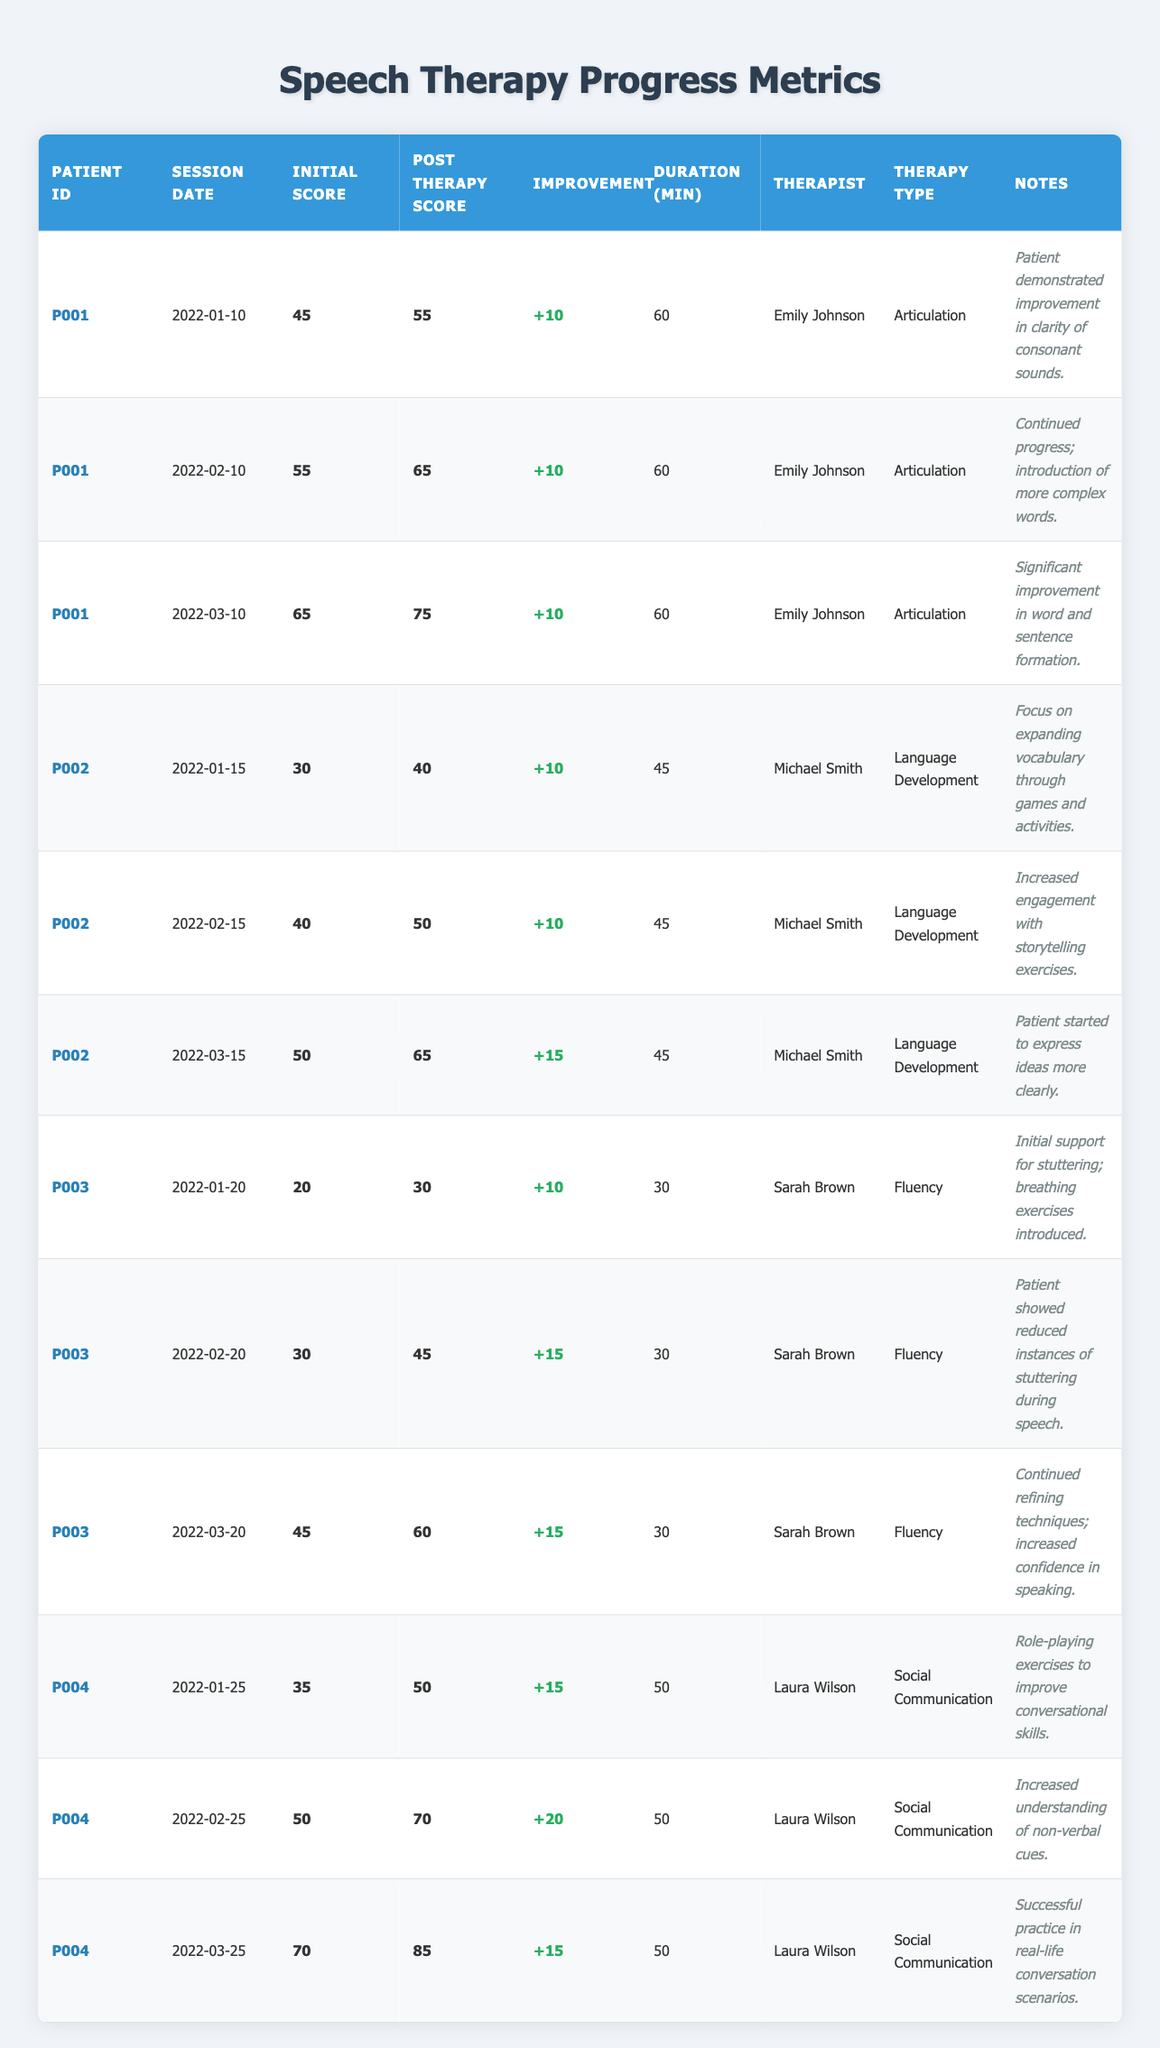What is the improvement score for patient P001 on the last session? In the last session for patient P001 on 2022-03-10, the post therapy score was 75 and the initial score was 65. Improvement is calculated as 75 - 65 = 10.
Answer: 10 Which therapist worked with patient P002 during the second session? During the second session on 2022-02-15, the therapist for patient P002 was Michael Smith, as noted in the table.
Answer: Michael Smith How much total improvement did patient P004 achieve from their first session to their last session? For patient P004, the initial score in the first session (2022-01-25) was 35 and the post therapy score in the last session (2022-03-25) was 85. Total improvement is calculated as 85 - 35 = 50.
Answer: 50 Did patient P003 show improvement in all their therapy sessions? In reviewing the table, patient P003's scores were 20 to 30 in the first session, 30 to 45 in the second, and 45 to 60 in the last. All post therapy scores were higher than their initial scores, indicating improvement in every session.
Answer: Yes What was the average session duration for patient P001 across all their sessions? Patient P001 had three sessions each lasting 60 minutes. To find the average, sum the durations (60 + 60 + 60 = 180) and divide by the number of sessions (3). Therefore, the average duration is 180 / 3 = 60 minutes.
Answer: 60 minutes How many total sessions did each patient have? From the table, patient P001 had 3 sessions, patient P002 had 3 sessions, patient P003 had 3 sessions, and patient P004 also had 3 sessions. Each patient had the same total of 3 sessions.
Answer: 3 sessions What was the highest post therapy score achieved by any patient? Reviewing the post therapy scores, the highest was achieved by patient P004 in the last session with a score of 85. This is the maximum value across all entries.
Answer: 85 Did any patients experience an improvement of more than 20 points in a single session? Looking through the improvements, patient P004 observed an improvement of 20 points between the second (50 to 70) and first (35 to 50) sessions. No other improvement values exceeded 20 points.
Answer: Yes 